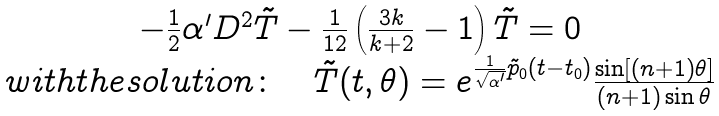<formula> <loc_0><loc_0><loc_500><loc_500>\begin{array} { c } { { - \frac { 1 } { 2 } \alpha ^ { \prime } D ^ { 2 } \tilde { T } - \frac { 1 } { 1 2 } \left ( \frac { 3 k } { k + 2 } - 1 \right ) \tilde { T } = 0 } } \\ { { w i t h t h e s o l u t i o n \colon \quad \tilde { T } ( t , \theta ) = e ^ { \frac { 1 } { \sqrt { \alpha ^ { \prime } } } \tilde { p } _ { 0 } ( t - t _ { 0 } ) } \frac { \sin [ ( n + 1 ) \theta ] } { ( n + 1 ) \sin \theta } } } \end{array}</formula> 